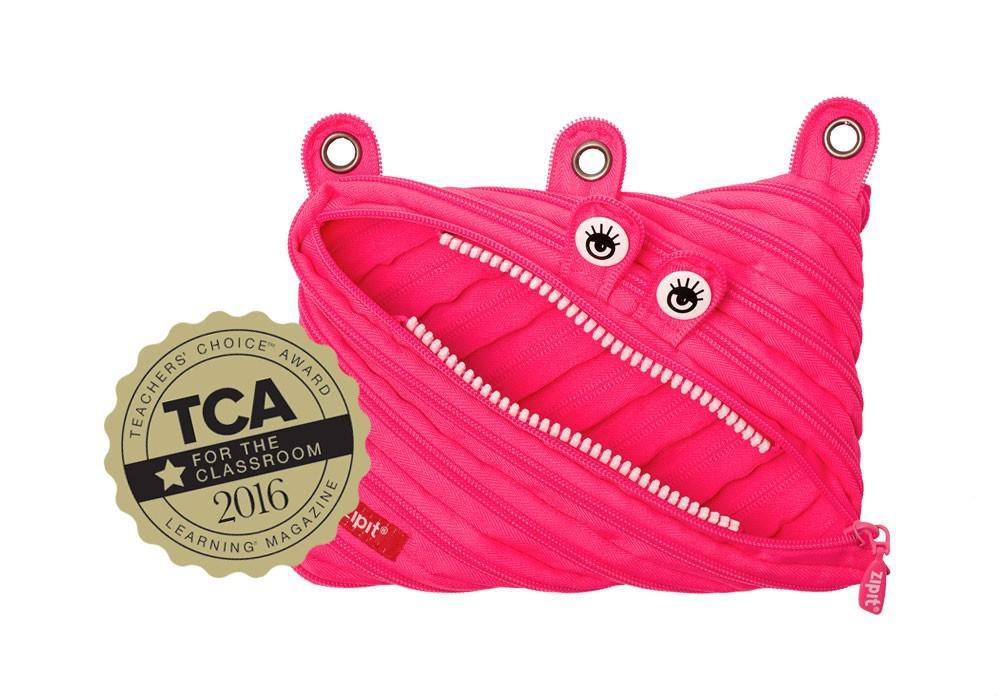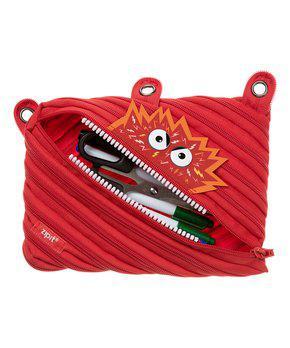The first image is the image on the left, the second image is the image on the right. Considering the images on both sides, is "One pouch is pink and the other pouch is red." valid? Answer yes or no. Yes. The first image is the image on the left, the second image is the image on the right. Considering the images on both sides, is "At least one of the pouches has holes along the top to fit it into a three-ring binder." valid? Answer yes or no. Yes. 